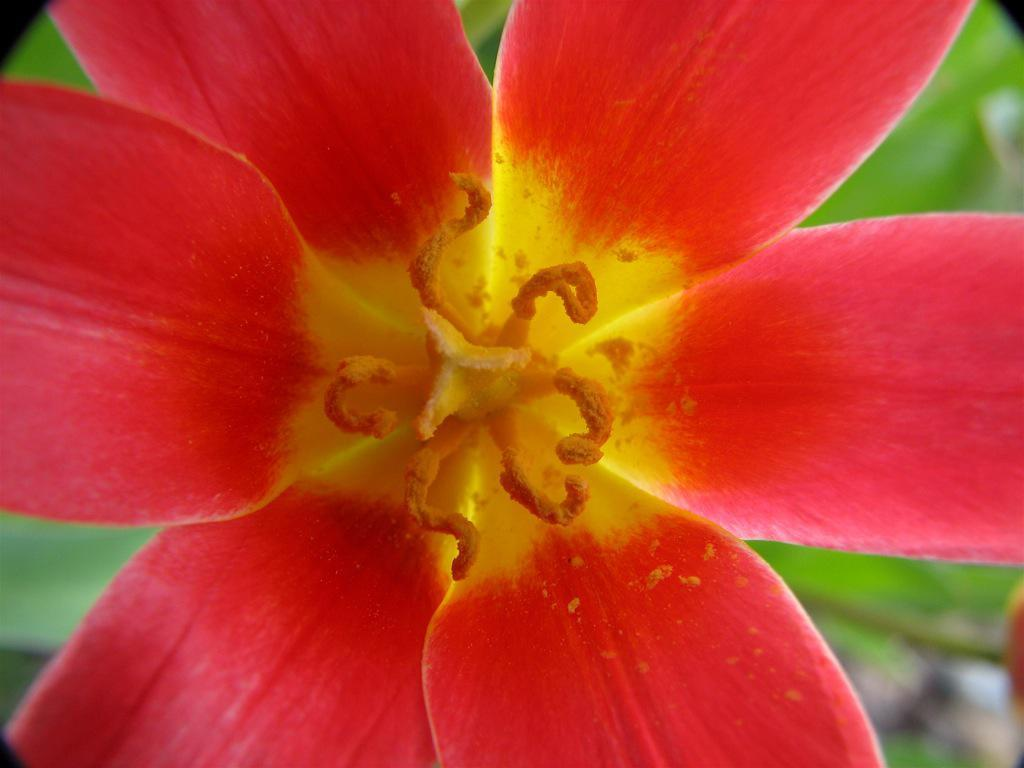What is the main subject of the image? There is a flower in the image. How would you describe the appearance of the flower? The flower is beautiful. What can be found on the flower? The flower has pollen grains. What is the color of the pollen grains? The pollen grains are in yellow color. What year is depicted in the image? There is no year depicted in the image, as it features a flower with pollen grains. How many toes can be seen on the flower in the image? There are no toes present in the image, as it features a flower with pollen grains. 